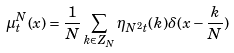<formula> <loc_0><loc_0><loc_500><loc_500>\mu _ { t } ^ { N } ( x ) = \frac { 1 } { N } \sum _ { k \in Z _ { N } } \eta _ { N ^ { 2 } t } ( k ) \delta ( x - \frac { k } { N } )</formula> 